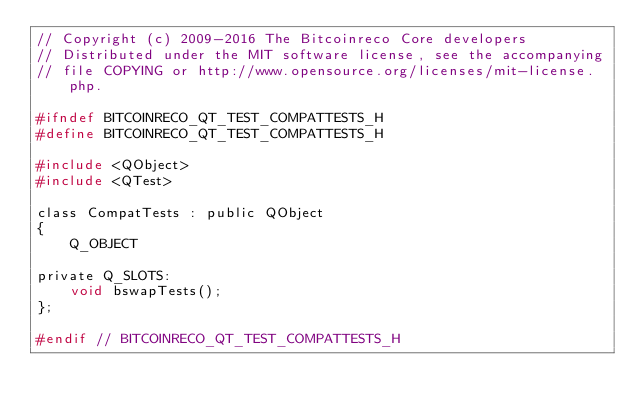<code> <loc_0><loc_0><loc_500><loc_500><_C_>// Copyright (c) 2009-2016 The Bitcoinreco Core developers
// Distributed under the MIT software license, see the accompanying
// file COPYING or http://www.opensource.org/licenses/mit-license.php.

#ifndef BITCOINRECO_QT_TEST_COMPATTESTS_H
#define BITCOINRECO_QT_TEST_COMPATTESTS_H

#include <QObject>
#include <QTest>

class CompatTests : public QObject
{
    Q_OBJECT

private Q_SLOTS:
    void bswapTests();
};

#endif // BITCOINRECO_QT_TEST_COMPATTESTS_H
</code> 